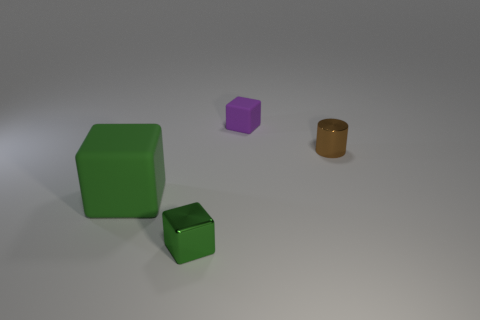There is a thing that is both on the right side of the large cube and to the left of the purple thing; what is its size?
Provide a succinct answer. Small. The small green object has what shape?
Ensure brevity in your answer.  Cube. Is there a green metallic object that is on the right side of the rubber thing on the right side of the small green shiny block?
Your response must be concise. No. There is a small metal thing in front of the brown object; what number of tiny blocks are in front of it?
Provide a succinct answer. 0. What material is the green thing that is the same size as the brown metal object?
Provide a short and direct response. Metal. There is a thing that is on the left side of the small metallic cube; does it have the same shape as the purple matte object?
Your response must be concise. Yes. Is the number of tiny metal things on the left side of the brown metallic thing greater than the number of big blocks to the right of the purple rubber thing?
Make the answer very short. Yes. What number of tiny red balls have the same material as the tiny purple object?
Your response must be concise. 0. Is the size of the purple cube the same as the cylinder?
Provide a succinct answer. Yes. What is the color of the cylinder?
Offer a very short reply. Brown. 